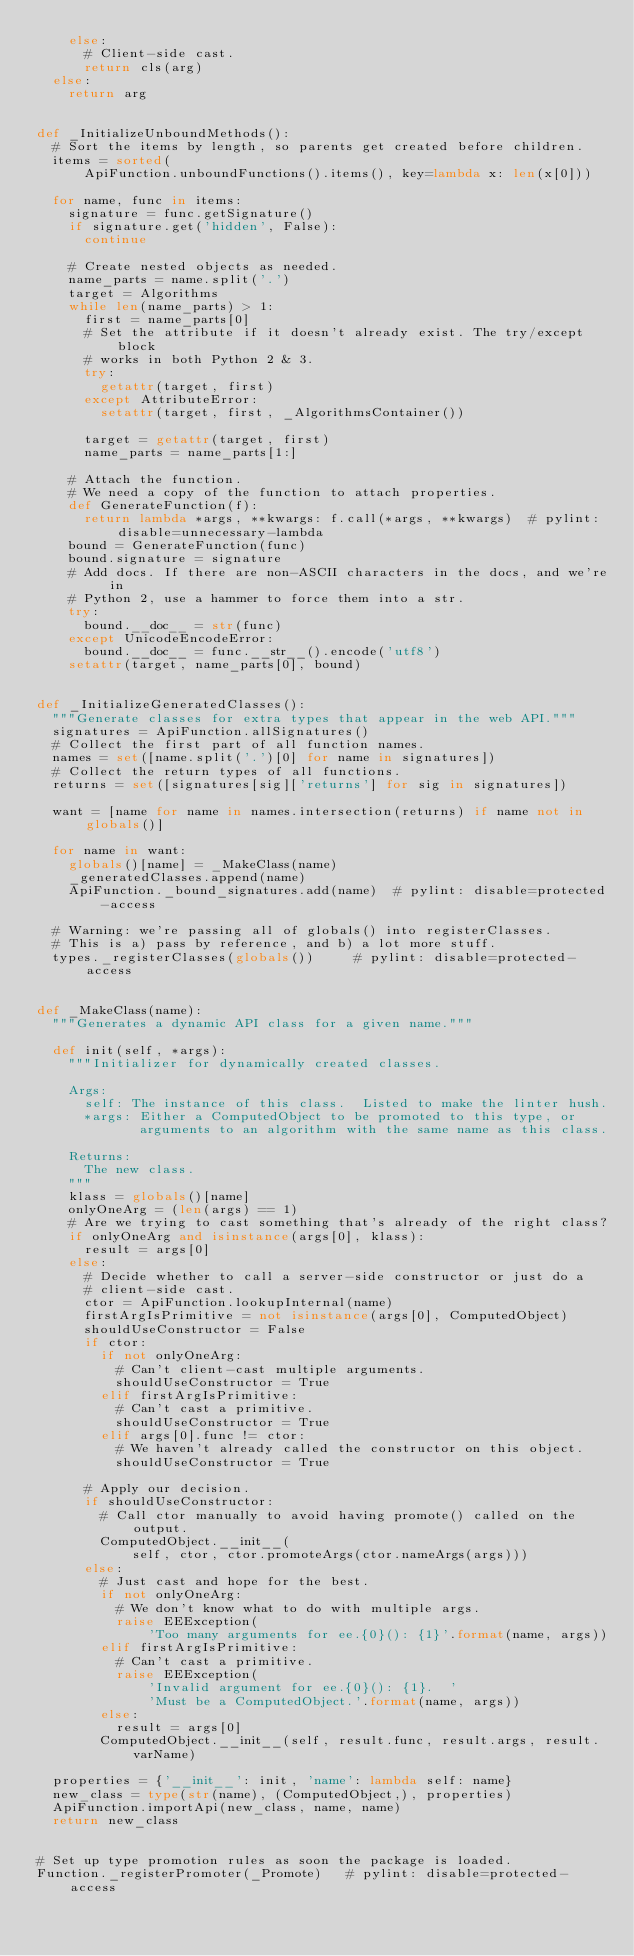<code> <loc_0><loc_0><loc_500><loc_500><_Python_>    else:
      # Client-side cast.
      return cls(arg)
  else:
    return arg


def _InitializeUnboundMethods():
  # Sort the items by length, so parents get created before children.
  items = sorted(
      ApiFunction.unboundFunctions().items(), key=lambda x: len(x[0]))

  for name, func in items:
    signature = func.getSignature()
    if signature.get('hidden', False):
      continue

    # Create nested objects as needed.
    name_parts = name.split('.')
    target = Algorithms
    while len(name_parts) > 1:
      first = name_parts[0]
      # Set the attribute if it doesn't already exist. The try/except block
      # works in both Python 2 & 3.
      try:
        getattr(target, first)
      except AttributeError:
        setattr(target, first, _AlgorithmsContainer())

      target = getattr(target, first)
      name_parts = name_parts[1:]

    # Attach the function.
    # We need a copy of the function to attach properties.
    def GenerateFunction(f):
      return lambda *args, **kwargs: f.call(*args, **kwargs)  # pylint: disable=unnecessary-lambda
    bound = GenerateFunction(func)
    bound.signature = signature
    # Add docs. If there are non-ASCII characters in the docs, and we're in
    # Python 2, use a hammer to force them into a str.
    try:
      bound.__doc__ = str(func)
    except UnicodeEncodeError:
      bound.__doc__ = func.__str__().encode('utf8')
    setattr(target, name_parts[0], bound)


def _InitializeGeneratedClasses():
  """Generate classes for extra types that appear in the web API."""
  signatures = ApiFunction.allSignatures()
  # Collect the first part of all function names.
  names = set([name.split('.')[0] for name in signatures])
  # Collect the return types of all functions.
  returns = set([signatures[sig]['returns'] for sig in signatures])

  want = [name for name in names.intersection(returns) if name not in globals()]

  for name in want:
    globals()[name] = _MakeClass(name)
    _generatedClasses.append(name)
    ApiFunction._bound_signatures.add(name)  # pylint: disable=protected-access

  # Warning: we're passing all of globals() into registerClasses.
  # This is a) pass by reference, and b) a lot more stuff.
  types._registerClasses(globals())     # pylint: disable=protected-access


def _MakeClass(name):
  """Generates a dynamic API class for a given name."""

  def init(self, *args):
    """Initializer for dynamically created classes.

    Args:
      self: The instance of this class.  Listed to make the linter hush.
      *args: Either a ComputedObject to be promoted to this type, or
             arguments to an algorithm with the same name as this class.

    Returns:
      The new class.
    """
    klass = globals()[name]
    onlyOneArg = (len(args) == 1)
    # Are we trying to cast something that's already of the right class?
    if onlyOneArg and isinstance(args[0], klass):
      result = args[0]
    else:
      # Decide whether to call a server-side constructor or just do a
      # client-side cast.
      ctor = ApiFunction.lookupInternal(name)
      firstArgIsPrimitive = not isinstance(args[0], ComputedObject)
      shouldUseConstructor = False
      if ctor:
        if not onlyOneArg:
          # Can't client-cast multiple arguments.
          shouldUseConstructor = True
        elif firstArgIsPrimitive:
          # Can't cast a primitive.
          shouldUseConstructor = True
        elif args[0].func != ctor:
          # We haven't already called the constructor on this object.
          shouldUseConstructor = True

      # Apply our decision.
      if shouldUseConstructor:
        # Call ctor manually to avoid having promote() called on the output.
        ComputedObject.__init__(
            self, ctor, ctor.promoteArgs(ctor.nameArgs(args)))
      else:
        # Just cast and hope for the best.
        if not onlyOneArg:
          # We don't know what to do with multiple args.
          raise EEException(
              'Too many arguments for ee.{0}(): {1}'.format(name, args))
        elif firstArgIsPrimitive:
          # Can't cast a primitive.
          raise EEException(
              'Invalid argument for ee.{0}(): {1}.  '
              'Must be a ComputedObject.'.format(name, args))
        else:
          result = args[0]
        ComputedObject.__init__(self, result.func, result.args, result.varName)

  properties = {'__init__': init, 'name': lambda self: name}
  new_class = type(str(name), (ComputedObject,), properties)
  ApiFunction.importApi(new_class, name, name)
  return new_class


# Set up type promotion rules as soon the package is loaded.
Function._registerPromoter(_Promote)   # pylint: disable=protected-access
</code> 